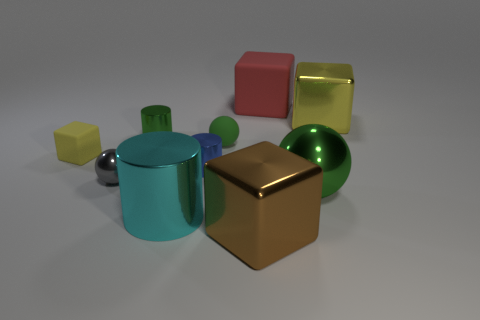What size is the yellow object that is in front of the small green metallic object?
Offer a very short reply. Small. What number of other things are there of the same material as the large ball
Provide a succinct answer. 6. There is a metallic cube to the left of the big yellow cube; are there any green rubber spheres to the right of it?
Provide a succinct answer. No. Are there any other things that are the same shape as the yellow matte thing?
Offer a very short reply. Yes. There is a large matte thing that is the same shape as the small yellow object; what color is it?
Your answer should be very brief. Red. What is the size of the red cube?
Offer a very short reply. Large. Are there fewer objects that are right of the large green metallic object than metal balls?
Make the answer very short. Yes. Does the brown thing have the same material as the green thing to the left of the big cyan thing?
Your answer should be compact. Yes. There is a matte object that is left of the tiny sphere that is right of the blue cylinder; is there a tiny green cylinder on the left side of it?
Give a very brief answer. No. Is there anything else that is the same size as the green cylinder?
Ensure brevity in your answer.  Yes. 